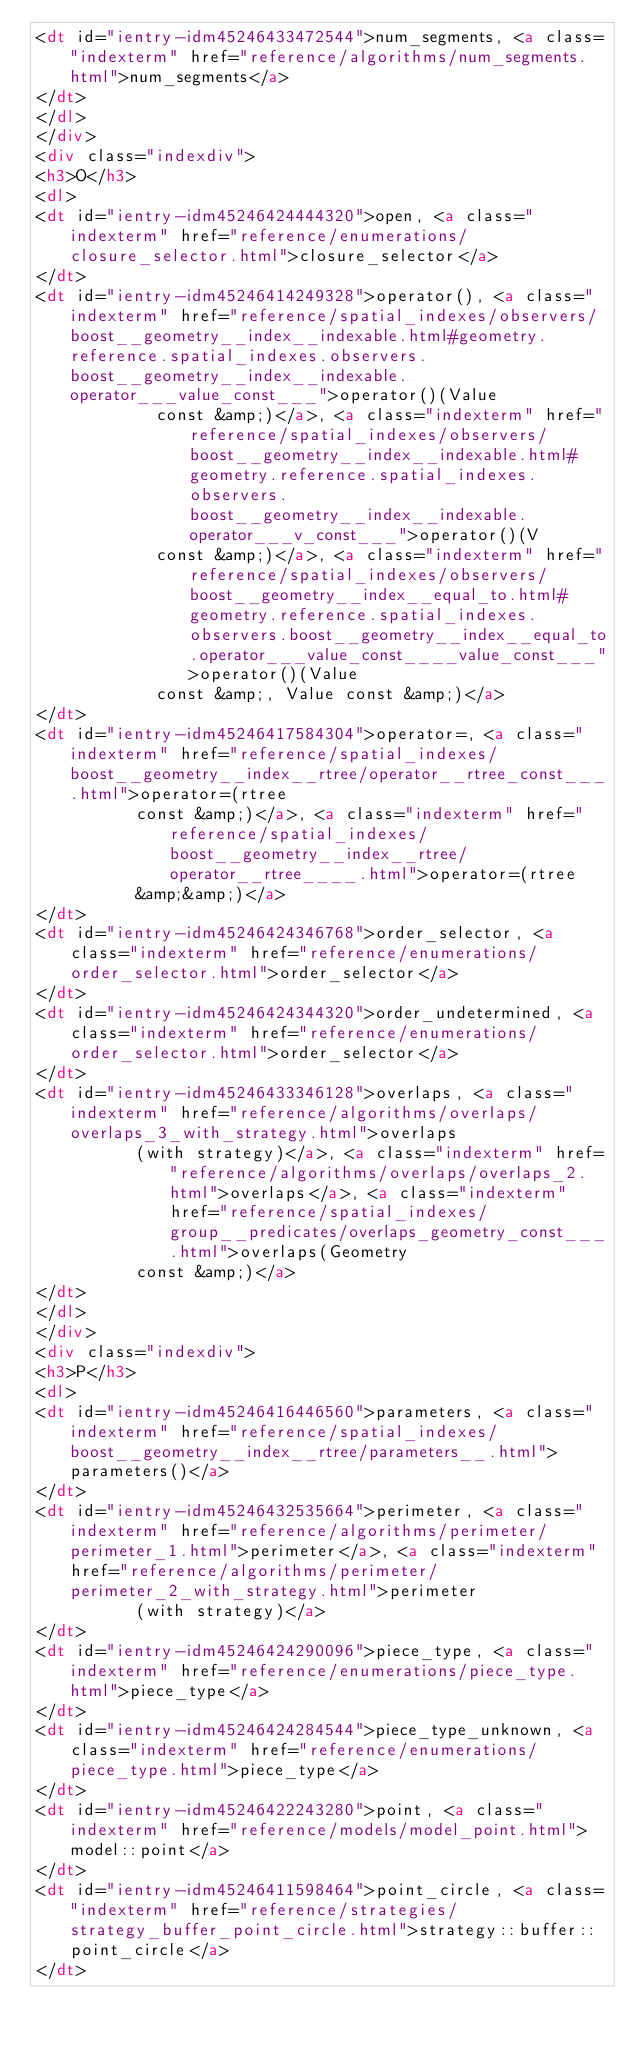<code> <loc_0><loc_0><loc_500><loc_500><_HTML_><dt id="ientry-idm45246433472544">num_segments, <a class="indexterm" href="reference/algorithms/num_segments.html">num_segments</a>
</dt>
</dl>
</div>
<div class="indexdiv">
<h3>O</h3>
<dl>
<dt id="ientry-idm45246424444320">open, <a class="indexterm" href="reference/enumerations/closure_selector.html">closure_selector</a>
</dt>
<dt id="ientry-idm45246414249328">operator(), <a class="indexterm" href="reference/spatial_indexes/observers/boost__geometry__index__indexable.html#geometry.reference.spatial_indexes.observers.boost__geometry__index__indexable.operator___value_const___">operator()(Value
            const &amp;)</a>, <a class="indexterm" href="reference/spatial_indexes/observers/boost__geometry__index__indexable.html#geometry.reference.spatial_indexes.observers.boost__geometry__index__indexable.operator___v_const___">operator()(V
            const &amp;)</a>, <a class="indexterm" href="reference/spatial_indexes/observers/boost__geometry__index__equal_to.html#geometry.reference.spatial_indexes.observers.boost__geometry__index__equal_to.operator___value_const____value_const___">operator()(Value
            const &amp;, Value const &amp;)</a>
</dt>
<dt id="ientry-idm45246417584304">operator=, <a class="indexterm" href="reference/spatial_indexes/boost__geometry__index__rtree/operator__rtree_const___.html">operator=(rtree
          const &amp;)</a>, <a class="indexterm" href="reference/spatial_indexes/boost__geometry__index__rtree/operator__rtree____.html">operator=(rtree
          &amp;&amp;)</a>
</dt>
<dt id="ientry-idm45246424346768">order_selector, <a class="indexterm" href="reference/enumerations/order_selector.html">order_selector</a>
</dt>
<dt id="ientry-idm45246424344320">order_undetermined, <a class="indexterm" href="reference/enumerations/order_selector.html">order_selector</a>
</dt>
<dt id="ientry-idm45246433346128">overlaps, <a class="indexterm" href="reference/algorithms/overlaps/overlaps_3_with_strategy.html">overlaps
          (with strategy)</a>, <a class="indexterm" href="reference/algorithms/overlaps/overlaps_2.html">overlaps</a>, <a class="indexterm" href="reference/spatial_indexes/group__predicates/overlaps_geometry_const___.html">overlaps(Geometry
          const &amp;)</a>
</dt>
</dl>
</div>
<div class="indexdiv">
<h3>P</h3>
<dl>
<dt id="ientry-idm45246416446560">parameters, <a class="indexterm" href="reference/spatial_indexes/boost__geometry__index__rtree/parameters__.html">parameters()</a>
</dt>
<dt id="ientry-idm45246432535664">perimeter, <a class="indexterm" href="reference/algorithms/perimeter/perimeter_1.html">perimeter</a>, <a class="indexterm" href="reference/algorithms/perimeter/perimeter_2_with_strategy.html">perimeter
          (with strategy)</a>
</dt>
<dt id="ientry-idm45246424290096">piece_type, <a class="indexterm" href="reference/enumerations/piece_type.html">piece_type</a>
</dt>
<dt id="ientry-idm45246424284544">piece_type_unknown, <a class="indexterm" href="reference/enumerations/piece_type.html">piece_type</a>
</dt>
<dt id="ientry-idm45246422243280">point, <a class="indexterm" href="reference/models/model_point.html">model::point</a>
</dt>
<dt id="ientry-idm45246411598464">point_circle, <a class="indexterm" href="reference/strategies/strategy_buffer_point_circle.html">strategy::buffer::point_circle</a>
</dt></code> 